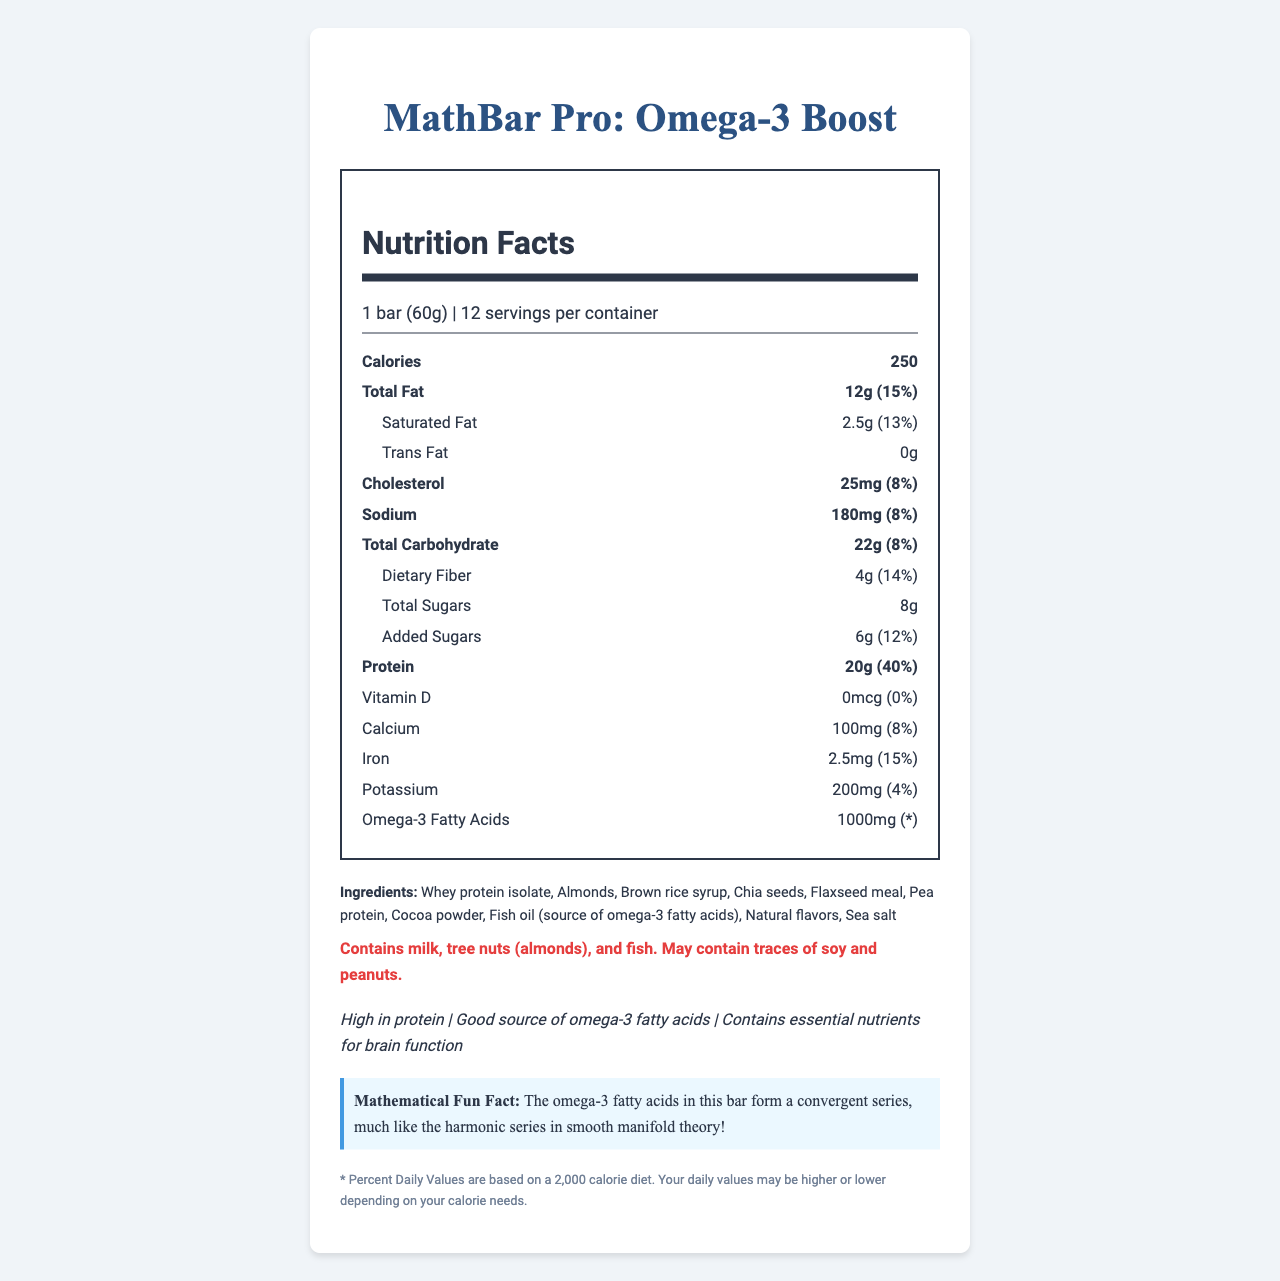what is the serving size of MathBar Pro: Omega-3 Boost? The serving size is mentioned under "serving info" which reads "1 bar (60g)".
Answer: 1 bar (60g) how many calories are in one serving of the energy bar? The calories per serving are listed directly under the "Calories" section.
Answer: 250 what are the main ingredients in the energy bar? The section under "Ingredients" lists all the main ingredients used.
Answer: Whey protein isolate, Almonds, Brown rice syrup, Chia seeds, Flaxseed meal, Pea protein, Cocoa powder, Fish oil (source of omega-3 fatty acids), Natural flavors, Sea salt what is the total fat content in one serving? The total fat content is listed as "12g" with a "Daily Value" percentage of "15%".
Answer: 12g (15%) Which of the following contains the highest percentage of Daily Value in MathBar Pro: Omega-3 Boost? A. Sodium B. Protein C. Iron D. Saturated Fat The protein content has a Daily Value percentage of 40%, which is the highest among the options listed.
Answer: B how much omega-3 fatty acids does the bar contain? Omega-3 Fatty Acids are listed with an amount of 1000mg.
Answer: 1000mg is this energy bar high in protein? The claim statement explicitly mentions "High in protein".
Answer: Yes summarize the main nutritional benefits of MathBar Pro: Omega-3 Boost. The claim statements collectively describe the main nutritional benefits.
Answer: High in protein, good source of omega-3 fatty acids, contains essential nutrients for brain function how much cholesterol is in one serving? The cholesterol content is listed as "25mg" with a "Daily Value" percentage of "8%".
Answer: 25mg (8%) what is the total carbohydrate content in one serving? The total carbohydrate amount is listed as "22g" with a "Daily Value" percentage of "8%".
Answer: 22g (8%) True or False: The energy bar contains no sugars. The total sugars listed are 8g, with added sugars being 6g.
Answer: False what allergens are present in this energy bar? The allergen information states these allergens explicitly.
Answer: Milk, tree nuts (almonds), fish; may contain traces of soy and peanuts how many bars are included in one container? The serving info indicates there are "12 servings per container".
Answer: 12 how much dietary fiber is in one serving of the energy bar? The dietary fiber content is listed as "4g" with a "Daily Value" percentage of "14%".
Answer: 4g (14%) how much potassium is in each bar? The potassium amount is listed as "200mg" with a "Daily Value" percentage of "4%".
Answer: 200mg (4%) how does the bar contribute to daily iron intake? The iron amount is listed as "2.5mg" with a "Daily Value" percentage of "15%".
Answer: 2.5mg (15%) What is the primary source of omega-3s in the bar? I. Chia seeds II. Flaxseed III. Fish oil IV. Brown rice syrup The ingredients list mentions "Fish oil (source of omega-3 fatty acids)" as the primary source.
Answer: III what is the mathematical fun fact mentioned on the nutrition facts label? This fun fact is specifically mentioned in a section titled "Mathematical Fun Fact".
Answer: The omega-3 fatty acids in this bar form a convergent series, much like the harmonic series in smooth manifold theory! What is the total percentage of Daily Value for Vitamin D in the MathBar Pro? The document lists "Vitamin D" as "0mcg (0%)".
Answer: 0% what is the % daily value of added sugars in the bar? The added sugars are listed as "6g (12%)".
Answer: 12% Does the bar contain Vitamin C? The document does not mention Vitamin C in its nutritional content.
Answer: Not enough information 